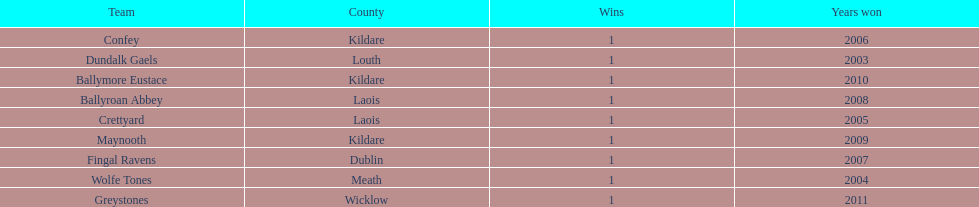What is the difference years won for crettyard and greystones 6. 